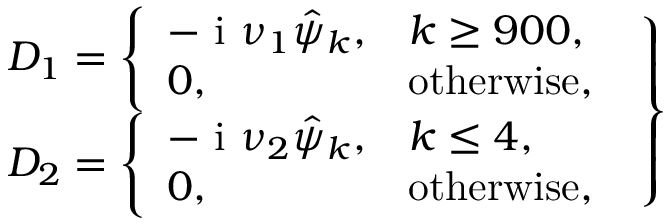Convert formula to latex. <formula><loc_0><loc_0><loc_500><loc_500>\begin{array} { r } { D _ { 1 } = \left \{ \begin{array} { l l } { - i \nu _ { 1 } \hat { \psi } _ { k } , } & { k \geq 9 0 0 , } \\ { 0 , } & { o t h e r w i s e , } \end{array} } \\ { D _ { 2 } = \left \{ \begin{array} { l l } { - i \nu _ { 2 } \hat { \psi } _ { k } , } & { k \leq 4 , } \\ { 0 , } & { o t h e r w i s e , } \end{array} } \end{array} \right \}</formula> 